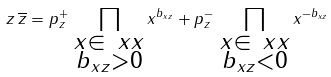Convert formula to latex. <formula><loc_0><loc_0><loc_500><loc_500>z \, \overline { z } = p _ { z } ^ { + } \, \prod _ { \substack { x \in \ x x \\ b _ { x z } > 0 } } x ^ { b _ { x z } } + p _ { z } ^ { - } \, \prod _ { \substack { x \in \ x x \\ b _ { x z } < 0 } } x ^ { - b _ { x z } }</formula> 